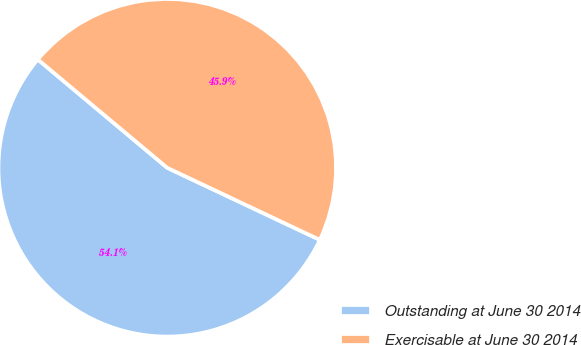<chart> <loc_0><loc_0><loc_500><loc_500><pie_chart><fcel>Outstanding at June 30 2014<fcel>Exercisable at June 30 2014<nl><fcel>54.07%<fcel>45.93%<nl></chart> 